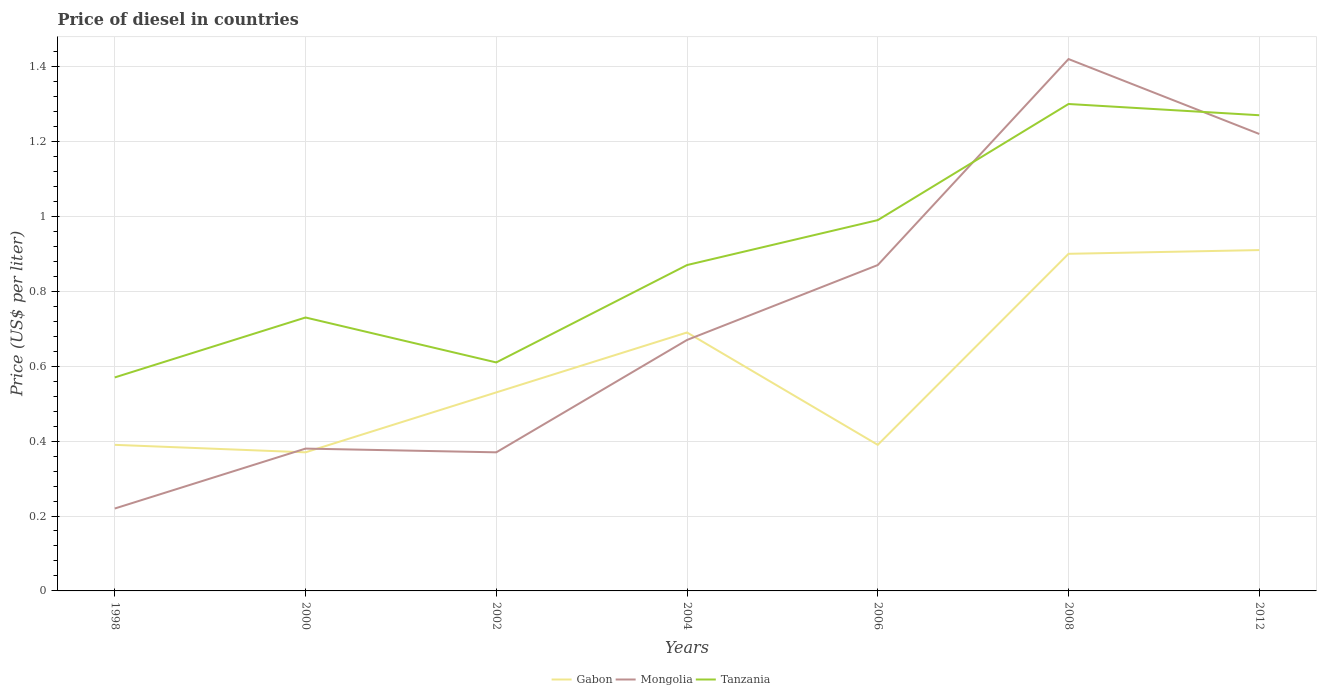Is the number of lines equal to the number of legend labels?
Provide a succinct answer. Yes. Across all years, what is the maximum price of diesel in Tanzania?
Make the answer very short. 0.57. In which year was the price of diesel in Tanzania maximum?
Your response must be concise. 1998. What is the difference between the highest and the second highest price of diesel in Tanzania?
Keep it short and to the point. 0.73. What is the difference between the highest and the lowest price of diesel in Gabon?
Offer a very short reply. 3. Is the price of diesel in Tanzania strictly greater than the price of diesel in Mongolia over the years?
Make the answer very short. No. What is the difference between two consecutive major ticks on the Y-axis?
Make the answer very short. 0.2. Are the values on the major ticks of Y-axis written in scientific E-notation?
Provide a short and direct response. No. Does the graph contain grids?
Provide a short and direct response. Yes. How are the legend labels stacked?
Make the answer very short. Horizontal. What is the title of the graph?
Ensure brevity in your answer.  Price of diesel in countries. What is the label or title of the X-axis?
Offer a very short reply. Years. What is the label or title of the Y-axis?
Provide a short and direct response. Price (US$ per liter). What is the Price (US$ per liter) of Gabon in 1998?
Ensure brevity in your answer.  0.39. What is the Price (US$ per liter) of Mongolia in 1998?
Offer a terse response. 0.22. What is the Price (US$ per liter) of Tanzania in 1998?
Ensure brevity in your answer.  0.57. What is the Price (US$ per liter) in Gabon in 2000?
Your answer should be compact. 0.37. What is the Price (US$ per liter) of Mongolia in 2000?
Provide a succinct answer. 0.38. What is the Price (US$ per liter) in Tanzania in 2000?
Your answer should be compact. 0.73. What is the Price (US$ per liter) of Gabon in 2002?
Your answer should be very brief. 0.53. What is the Price (US$ per liter) in Mongolia in 2002?
Your answer should be compact. 0.37. What is the Price (US$ per liter) of Tanzania in 2002?
Provide a succinct answer. 0.61. What is the Price (US$ per liter) in Gabon in 2004?
Offer a very short reply. 0.69. What is the Price (US$ per liter) of Mongolia in 2004?
Your answer should be compact. 0.67. What is the Price (US$ per liter) of Tanzania in 2004?
Make the answer very short. 0.87. What is the Price (US$ per liter) in Gabon in 2006?
Offer a terse response. 0.39. What is the Price (US$ per liter) in Mongolia in 2006?
Your response must be concise. 0.87. What is the Price (US$ per liter) in Tanzania in 2006?
Provide a short and direct response. 0.99. What is the Price (US$ per liter) in Gabon in 2008?
Keep it short and to the point. 0.9. What is the Price (US$ per liter) in Mongolia in 2008?
Your response must be concise. 1.42. What is the Price (US$ per liter) of Gabon in 2012?
Keep it short and to the point. 0.91. What is the Price (US$ per liter) of Mongolia in 2012?
Give a very brief answer. 1.22. What is the Price (US$ per liter) in Tanzania in 2012?
Your response must be concise. 1.27. Across all years, what is the maximum Price (US$ per liter) of Gabon?
Offer a terse response. 0.91. Across all years, what is the maximum Price (US$ per liter) in Mongolia?
Provide a short and direct response. 1.42. Across all years, what is the minimum Price (US$ per liter) of Gabon?
Offer a very short reply. 0.37. Across all years, what is the minimum Price (US$ per liter) in Mongolia?
Your answer should be compact. 0.22. Across all years, what is the minimum Price (US$ per liter) in Tanzania?
Offer a terse response. 0.57. What is the total Price (US$ per liter) of Gabon in the graph?
Your response must be concise. 4.18. What is the total Price (US$ per liter) of Mongolia in the graph?
Provide a short and direct response. 5.15. What is the total Price (US$ per liter) of Tanzania in the graph?
Ensure brevity in your answer.  6.34. What is the difference between the Price (US$ per liter) in Gabon in 1998 and that in 2000?
Your answer should be very brief. 0.02. What is the difference between the Price (US$ per liter) in Mongolia in 1998 and that in 2000?
Offer a very short reply. -0.16. What is the difference between the Price (US$ per liter) of Tanzania in 1998 and that in 2000?
Ensure brevity in your answer.  -0.16. What is the difference between the Price (US$ per liter) in Gabon in 1998 and that in 2002?
Ensure brevity in your answer.  -0.14. What is the difference between the Price (US$ per liter) in Mongolia in 1998 and that in 2002?
Give a very brief answer. -0.15. What is the difference between the Price (US$ per liter) in Tanzania in 1998 and that in 2002?
Your answer should be very brief. -0.04. What is the difference between the Price (US$ per liter) of Mongolia in 1998 and that in 2004?
Give a very brief answer. -0.45. What is the difference between the Price (US$ per liter) in Tanzania in 1998 and that in 2004?
Provide a short and direct response. -0.3. What is the difference between the Price (US$ per liter) in Mongolia in 1998 and that in 2006?
Give a very brief answer. -0.65. What is the difference between the Price (US$ per liter) in Tanzania in 1998 and that in 2006?
Make the answer very short. -0.42. What is the difference between the Price (US$ per liter) in Gabon in 1998 and that in 2008?
Keep it short and to the point. -0.51. What is the difference between the Price (US$ per liter) of Tanzania in 1998 and that in 2008?
Ensure brevity in your answer.  -0.73. What is the difference between the Price (US$ per liter) of Gabon in 1998 and that in 2012?
Give a very brief answer. -0.52. What is the difference between the Price (US$ per liter) in Tanzania in 1998 and that in 2012?
Give a very brief answer. -0.7. What is the difference between the Price (US$ per liter) in Gabon in 2000 and that in 2002?
Ensure brevity in your answer.  -0.16. What is the difference between the Price (US$ per liter) of Tanzania in 2000 and that in 2002?
Provide a succinct answer. 0.12. What is the difference between the Price (US$ per liter) of Gabon in 2000 and that in 2004?
Give a very brief answer. -0.32. What is the difference between the Price (US$ per liter) in Mongolia in 2000 and that in 2004?
Provide a short and direct response. -0.29. What is the difference between the Price (US$ per liter) of Tanzania in 2000 and that in 2004?
Offer a very short reply. -0.14. What is the difference between the Price (US$ per liter) in Gabon in 2000 and that in 2006?
Provide a succinct answer. -0.02. What is the difference between the Price (US$ per liter) in Mongolia in 2000 and that in 2006?
Your answer should be compact. -0.49. What is the difference between the Price (US$ per liter) in Tanzania in 2000 and that in 2006?
Your answer should be compact. -0.26. What is the difference between the Price (US$ per liter) in Gabon in 2000 and that in 2008?
Make the answer very short. -0.53. What is the difference between the Price (US$ per liter) in Mongolia in 2000 and that in 2008?
Your response must be concise. -1.04. What is the difference between the Price (US$ per liter) in Tanzania in 2000 and that in 2008?
Offer a very short reply. -0.57. What is the difference between the Price (US$ per liter) of Gabon in 2000 and that in 2012?
Provide a succinct answer. -0.54. What is the difference between the Price (US$ per liter) in Mongolia in 2000 and that in 2012?
Provide a succinct answer. -0.84. What is the difference between the Price (US$ per liter) of Tanzania in 2000 and that in 2012?
Make the answer very short. -0.54. What is the difference between the Price (US$ per liter) in Gabon in 2002 and that in 2004?
Ensure brevity in your answer.  -0.16. What is the difference between the Price (US$ per liter) in Tanzania in 2002 and that in 2004?
Ensure brevity in your answer.  -0.26. What is the difference between the Price (US$ per liter) of Gabon in 2002 and that in 2006?
Provide a succinct answer. 0.14. What is the difference between the Price (US$ per liter) in Tanzania in 2002 and that in 2006?
Keep it short and to the point. -0.38. What is the difference between the Price (US$ per liter) in Gabon in 2002 and that in 2008?
Offer a terse response. -0.37. What is the difference between the Price (US$ per liter) in Mongolia in 2002 and that in 2008?
Your response must be concise. -1.05. What is the difference between the Price (US$ per liter) of Tanzania in 2002 and that in 2008?
Offer a very short reply. -0.69. What is the difference between the Price (US$ per liter) of Gabon in 2002 and that in 2012?
Give a very brief answer. -0.38. What is the difference between the Price (US$ per liter) in Mongolia in 2002 and that in 2012?
Make the answer very short. -0.85. What is the difference between the Price (US$ per liter) in Tanzania in 2002 and that in 2012?
Your response must be concise. -0.66. What is the difference between the Price (US$ per liter) in Tanzania in 2004 and that in 2006?
Ensure brevity in your answer.  -0.12. What is the difference between the Price (US$ per liter) in Gabon in 2004 and that in 2008?
Your response must be concise. -0.21. What is the difference between the Price (US$ per liter) in Mongolia in 2004 and that in 2008?
Provide a succinct answer. -0.75. What is the difference between the Price (US$ per liter) of Tanzania in 2004 and that in 2008?
Provide a succinct answer. -0.43. What is the difference between the Price (US$ per liter) in Gabon in 2004 and that in 2012?
Offer a terse response. -0.22. What is the difference between the Price (US$ per liter) of Mongolia in 2004 and that in 2012?
Keep it short and to the point. -0.55. What is the difference between the Price (US$ per liter) of Gabon in 2006 and that in 2008?
Your answer should be very brief. -0.51. What is the difference between the Price (US$ per liter) in Mongolia in 2006 and that in 2008?
Keep it short and to the point. -0.55. What is the difference between the Price (US$ per liter) in Tanzania in 2006 and that in 2008?
Give a very brief answer. -0.31. What is the difference between the Price (US$ per liter) in Gabon in 2006 and that in 2012?
Give a very brief answer. -0.52. What is the difference between the Price (US$ per liter) in Mongolia in 2006 and that in 2012?
Give a very brief answer. -0.35. What is the difference between the Price (US$ per liter) of Tanzania in 2006 and that in 2012?
Provide a succinct answer. -0.28. What is the difference between the Price (US$ per liter) in Gabon in 2008 and that in 2012?
Make the answer very short. -0.01. What is the difference between the Price (US$ per liter) of Mongolia in 2008 and that in 2012?
Your answer should be compact. 0.2. What is the difference between the Price (US$ per liter) in Tanzania in 2008 and that in 2012?
Keep it short and to the point. 0.03. What is the difference between the Price (US$ per liter) in Gabon in 1998 and the Price (US$ per liter) in Tanzania in 2000?
Make the answer very short. -0.34. What is the difference between the Price (US$ per liter) of Mongolia in 1998 and the Price (US$ per liter) of Tanzania in 2000?
Your answer should be compact. -0.51. What is the difference between the Price (US$ per liter) in Gabon in 1998 and the Price (US$ per liter) in Tanzania in 2002?
Ensure brevity in your answer.  -0.22. What is the difference between the Price (US$ per liter) in Mongolia in 1998 and the Price (US$ per liter) in Tanzania in 2002?
Offer a terse response. -0.39. What is the difference between the Price (US$ per liter) in Gabon in 1998 and the Price (US$ per liter) in Mongolia in 2004?
Make the answer very short. -0.28. What is the difference between the Price (US$ per liter) of Gabon in 1998 and the Price (US$ per liter) of Tanzania in 2004?
Your answer should be very brief. -0.48. What is the difference between the Price (US$ per liter) of Mongolia in 1998 and the Price (US$ per liter) of Tanzania in 2004?
Offer a very short reply. -0.65. What is the difference between the Price (US$ per liter) of Gabon in 1998 and the Price (US$ per liter) of Mongolia in 2006?
Your response must be concise. -0.48. What is the difference between the Price (US$ per liter) of Gabon in 1998 and the Price (US$ per liter) of Tanzania in 2006?
Offer a very short reply. -0.6. What is the difference between the Price (US$ per liter) of Mongolia in 1998 and the Price (US$ per liter) of Tanzania in 2006?
Offer a very short reply. -0.77. What is the difference between the Price (US$ per liter) of Gabon in 1998 and the Price (US$ per liter) of Mongolia in 2008?
Ensure brevity in your answer.  -1.03. What is the difference between the Price (US$ per liter) in Gabon in 1998 and the Price (US$ per liter) in Tanzania in 2008?
Your answer should be very brief. -0.91. What is the difference between the Price (US$ per liter) in Mongolia in 1998 and the Price (US$ per liter) in Tanzania in 2008?
Offer a very short reply. -1.08. What is the difference between the Price (US$ per liter) in Gabon in 1998 and the Price (US$ per liter) in Mongolia in 2012?
Give a very brief answer. -0.83. What is the difference between the Price (US$ per liter) of Gabon in 1998 and the Price (US$ per liter) of Tanzania in 2012?
Offer a terse response. -0.88. What is the difference between the Price (US$ per liter) in Mongolia in 1998 and the Price (US$ per liter) in Tanzania in 2012?
Your answer should be very brief. -1.05. What is the difference between the Price (US$ per liter) of Gabon in 2000 and the Price (US$ per liter) of Mongolia in 2002?
Offer a terse response. 0. What is the difference between the Price (US$ per liter) of Gabon in 2000 and the Price (US$ per liter) of Tanzania in 2002?
Offer a terse response. -0.24. What is the difference between the Price (US$ per liter) in Mongolia in 2000 and the Price (US$ per liter) in Tanzania in 2002?
Ensure brevity in your answer.  -0.23. What is the difference between the Price (US$ per liter) of Mongolia in 2000 and the Price (US$ per liter) of Tanzania in 2004?
Keep it short and to the point. -0.49. What is the difference between the Price (US$ per liter) of Gabon in 2000 and the Price (US$ per liter) of Tanzania in 2006?
Offer a terse response. -0.62. What is the difference between the Price (US$ per liter) in Mongolia in 2000 and the Price (US$ per liter) in Tanzania in 2006?
Keep it short and to the point. -0.61. What is the difference between the Price (US$ per liter) of Gabon in 2000 and the Price (US$ per liter) of Mongolia in 2008?
Ensure brevity in your answer.  -1.05. What is the difference between the Price (US$ per liter) of Gabon in 2000 and the Price (US$ per liter) of Tanzania in 2008?
Keep it short and to the point. -0.93. What is the difference between the Price (US$ per liter) of Mongolia in 2000 and the Price (US$ per liter) of Tanzania in 2008?
Give a very brief answer. -0.92. What is the difference between the Price (US$ per liter) in Gabon in 2000 and the Price (US$ per liter) in Mongolia in 2012?
Make the answer very short. -0.85. What is the difference between the Price (US$ per liter) of Mongolia in 2000 and the Price (US$ per liter) of Tanzania in 2012?
Provide a short and direct response. -0.89. What is the difference between the Price (US$ per liter) of Gabon in 2002 and the Price (US$ per liter) of Mongolia in 2004?
Give a very brief answer. -0.14. What is the difference between the Price (US$ per liter) in Gabon in 2002 and the Price (US$ per liter) in Tanzania in 2004?
Ensure brevity in your answer.  -0.34. What is the difference between the Price (US$ per liter) of Gabon in 2002 and the Price (US$ per liter) of Mongolia in 2006?
Provide a succinct answer. -0.34. What is the difference between the Price (US$ per liter) in Gabon in 2002 and the Price (US$ per liter) in Tanzania in 2006?
Ensure brevity in your answer.  -0.46. What is the difference between the Price (US$ per liter) of Mongolia in 2002 and the Price (US$ per liter) of Tanzania in 2006?
Provide a succinct answer. -0.62. What is the difference between the Price (US$ per liter) of Gabon in 2002 and the Price (US$ per liter) of Mongolia in 2008?
Give a very brief answer. -0.89. What is the difference between the Price (US$ per liter) in Gabon in 2002 and the Price (US$ per liter) in Tanzania in 2008?
Provide a short and direct response. -0.77. What is the difference between the Price (US$ per liter) in Mongolia in 2002 and the Price (US$ per liter) in Tanzania in 2008?
Keep it short and to the point. -0.93. What is the difference between the Price (US$ per liter) in Gabon in 2002 and the Price (US$ per liter) in Mongolia in 2012?
Your answer should be compact. -0.69. What is the difference between the Price (US$ per liter) of Gabon in 2002 and the Price (US$ per liter) of Tanzania in 2012?
Ensure brevity in your answer.  -0.74. What is the difference between the Price (US$ per liter) of Gabon in 2004 and the Price (US$ per liter) of Mongolia in 2006?
Keep it short and to the point. -0.18. What is the difference between the Price (US$ per liter) in Mongolia in 2004 and the Price (US$ per liter) in Tanzania in 2006?
Ensure brevity in your answer.  -0.32. What is the difference between the Price (US$ per liter) of Gabon in 2004 and the Price (US$ per liter) of Mongolia in 2008?
Provide a succinct answer. -0.73. What is the difference between the Price (US$ per liter) in Gabon in 2004 and the Price (US$ per liter) in Tanzania in 2008?
Provide a short and direct response. -0.61. What is the difference between the Price (US$ per liter) of Mongolia in 2004 and the Price (US$ per liter) of Tanzania in 2008?
Offer a terse response. -0.63. What is the difference between the Price (US$ per liter) in Gabon in 2004 and the Price (US$ per liter) in Mongolia in 2012?
Your answer should be compact. -0.53. What is the difference between the Price (US$ per liter) in Gabon in 2004 and the Price (US$ per liter) in Tanzania in 2012?
Give a very brief answer. -0.58. What is the difference between the Price (US$ per liter) in Mongolia in 2004 and the Price (US$ per liter) in Tanzania in 2012?
Provide a succinct answer. -0.6. What is the difference between the Price (US$ per liter) of Gabon in 2006 and the Price (US$ per liter) of Mongolia in 2008?
Ensure brevity in your answer.  -1.03. What is the difference between the Price (US$ per liter) of Gabon in 2006 and the Price (US$ per liter) of Tanzania in 2008?
Make the answer very short. -0.91. What is the difference between the Price (US$ per liter) in Mongolia in 2006 and the Price (US$ per liter) in Tanzania in 2008?
Offer a very short reply. -0.43. What is the difference between the Price (US$ per liter) in Gabon in 2006 and the Price (US$ per liter) in Mongolia in 2012?
Offer a terse response. -0.83. What is the difference between the Price (US$ per liter) of Gabon in 2006 and the Price (US$ per liter) of Tanzania in 2012?
Provide a short and direct response. -0.88. What is the difference between the Price (US$ per liter) in Gabon in 2008 and the Price (US$ per liter) in Mongolia in 2012?
Keep it short and to the point. -0.32. What is the difference between the Price (US$ per liter) of Gabon in 2008 and the Price (US$ per liter) of Tanzania in 2012?
Provide a short and direct response. -0.37. What is the average Price (US$ per liter) of Gabon per year?
Provide a succinct answer. 0.6. What is the average Price (US$ per liter) in Mongolia per year?
Offer a terse response. 0.74. What is the average Price (US$ per liter) of Tanzania per year?
Keep it short and to the point. 0.91. In the year 1998, what is the difference between the Price (US$ per liter) of Gabon and Price (US$ per liter) of Mongolia?
Ensure brevity in your answer.  0.17. In the year 1998, what is the difference between the Price (US$ per liter) of Gabon and Price (US$ per liter) of Tanzania?
Your answer should be very brief. -0.18. In the year 1998, what is the difference between the Price (US$ per liter) of Mongolia and Price (US$ per liter) of Tanzania?
Your answer should be very brief. -0.35. In the year 2000, what is the difference between the Price (US$ per liter) in Gabon and Price (US$ per liter) in Mongolia?
Provide a short and direct response. -0.01. In the year 2000, what is the difference between the Price (US$ per liter) in Gabon and Price (US$ per liter) in Tanzania?
Make the answer very short. -0.36. In the year 2000, what is the difference between the Price (US$ per liter) in Mongolia and Price (US$ per liter) in Tanzania?
Your answer should be very brief. -0.35. In the year 2002, what is the difference between the Price (US$ per liter) of Gabon and Price (US$ per liter) of Mongolia?
Keep it short and to the point. 0.16. In the year 2002, what is the difference between the Price (US$ per liter) in Gabon and Price (US$ per liter) in Tanzania?
Your response must be concise. -0.08. In the year 2002, what is the difference between the Price (US$ per liter) in Mongolia and Price (US$ per liter) in Tanzania?
Offer a terse response. -0.24. In the year 2004, what is the difference between the Price (US$ per liter) in Gabon and Price (US$ per liter) in Mongolia?
Your response must be concise. 0.02. In the year 2004, what is the difference between the Price (US$ per liter) in Gabon and Price (US$ per liter) in Tanzania?
Offer a very short reply. -0.18. In the year 2006, what is the difference between the Price (US$ per liter) in Gabon and Price (US$ per liter) in Mongolia?
Make the answer very short. -0.48. In the year 2006, what is the difference between the Price (US$ per liter) of Mongolia and Price (US$ per liter) of Tanzania?
Make the answer very short. -0.12. In the year 2008, what is the difference between the Price (US$ per liter) of Gabon and Price (US$ per liter) of Mongolia?
Your answer should be compact. -0.52. In the year 2008, what is the difference between the Price (US$ per liter) of Mongolia and Price (US$ per liter) of Tanzania?
Your answer should be very brief. 0.12. In the year 2012, what is the difference between the Price (US$ per liter) of Gabon and Price (US$ per liter) of Mongolia?
Your response must be concise. -0.31. In the year 2012, what is the difference between the Price (US$ per liter) in Gabon and Price (US$ per liter) in Tanzania?
Offer a terse response. -0.36. In the year 2012, what is the difference between the Price (US$ per liter) in Mongolia and Price (US$ per liter) in Tanzania?
Your answer should be compact. -0.05. What is the ratio of the Price (US$ per liter) of Gabon in 1998 to that in 2000?
Your answer should be compact. 1.05. What is the ratio of the Price (US$ per liter) in Mongolia in 1998 to that in 2000?
Make the answer very short. 0.58. What is the ratio of the Price (US$ per liter) in Tanzania in 1998 to that in 2000?
Make the answer very short. 0.78. What is the ratio of the Price (US$ per liter) in Gabon in 1998 to that in 2002?
Your response must be concise. 0.74. What is the ratio of the Price (US$ per liter) of Mongolia in 1998 to that in 2002?
Keep it short and to the point. 0.59. What is the ratio of the Price (US$ per liter) in Tanzania in 1998 to that in 2002?
Offer a terse response. 0.93. What is the ratio of the Price (US$ per liter) of Gabon in 1998 to that in 2004?
Keep it short and to the point. 0.57. What is the ratio of the Price (US$ per liter) of Mongolia in 1998 to that in 2004?
Offer a very short reply. 0.33. What is the ratio of the Price (US$ per liter) of Tanzania in 1998 to that in 2004?
Your answer should be compact. 0.66. What is the ratio of the Price (US$ per liter) of Gabon in 1998 to that in 2006?
Your answer should be very brief. 1. What is the ratio of the Price (US$ per liter) in Mongolia in 1998 to that in 2006?
Offer a terse response. 0.25. What is the ratio of the Price (US$ per liter) of Tanzania in 1998 to that in 2006?
Provide a short and direct response. 0.58. What is the ratio of the Price (US$ per liter) in Gabon in 1998 to that in 2008?
Provide a short and direct response. 0.43. What is the ratio of the Price (US$ per liter) of Mongolia in 1998 to that in 2008?
Keep it short and to the point. 0.15. What is the ratio of the Price (US$ per liter) of Tanzania in 1998 to that in 2008?
Make the answer very short. 0.44. What is the ratio of the Price (US$ per liter) of Gabon in 1998 to that in 2012?
Offer a terse response. 0.43. What is the ratio of the Price (US$ per liter) of Mongolia in 1998 to that in 2012?
Your response must be concise. 0.18. What is the ratio of the Price (US$ per liter) of Tanzania in 1998 to that in 2012?
Keep it short and to the point. 0.45. What is the ratio of the Price (US$ per liter) of Gabon in 2000 to that in 2002?
Ensure brevity in your answer.  0.7. What is the ratio of the Price (US$ per liter) in Tanzania in 2000 to that in 2002?
Make the answer very short. 1.2. What is the ratio of the Price (US$ per liter) in Gabon in 2000 to that in 2004?
Provide a succinct answer. 0.54. What is the ratio of the Price (US$ per liter) in Mongolia in 2000 to that in 2004?
Your answer should be very brief. 0.57. What is the ratio of the Price (US$ per liter) of Tanzania in 2000 to that in 2004?
Your answer should be very brief. 0.84. What is the ratio of the Price (US$ per liter) in Gabon in 2000 to that in 2006?
Offer a terse response. 0.95. What is the ratio of the Price (US$ per liter) of Mongolia in 2000 to that in 2006?
Offer a very short reply. 0.44. What is the ratio of the Price (US$ per liter) in Tanzania in 2000 to that in 2006?
Your answer should be compact. 0.74. What is the ratio of the Price (US$ per liter) in Gabon in 2000 to that in 2008?
Provide a succinct answer. 0.41. What is the ratio of the Price (US$ per liter) in Mongolia in 2000 to that in 2008?
Your response must be concise. 0.27. What is the ratio of the Price (US$ per liter) of Tanzania in 2000 to that in 2008?
Offer a very short reply. 0.56. What is the ratio of the Price (US$ per liter) of Gabon in 2000 to that in 2012?
Give a very brief answer. 0.41. What is the ratio of the Price (US$ per liter) of Mongolia in 2000 to that in 2012?
Provide a succinct answer. 0.31. What is the ratio of the Price (US$ per liter) in Tanzania in 2000 to that in 2012?
Your answer should be very brief. 0.57. What is the ratio of the Price (US$ per liter) in Gabon in 2002 to that in 2004?
Give a very brief answer. 0.77. What is the ratio of the Price (US$ per liter) in Mongolia in 2002 to that in 2004?
Offer a very short reply. 0.55. What is the ratio of the Price (US$ per liter) of Tanzania in 2002 to that in 2004?
Offer a very short reply. 0.7. What is the ratio of the Price (US$ per liter) in Gabon in 2002 to that in 2006?
Your answer should be compact. 1.36. What is the ratio of the Price (US$ per liter) of Mongolia in 2002 to that in 2006?
Make the answer very short. 0.43. What is the ratio of the Price (US$ per liter) of Tanzania in 2002 to that in 2006?
Your answer should be compact. 0.62. What is the ratio of the Price (US$ per liter) of Gabon in 2002 to that in 2008?
Make the answer very short. 0.59. What is the ratio of the Price (US$ per liter) of Mongolia in 2002 to that in 2008?
Keep it short and to the point. 0.26. What is the ratio of the Price (US$ per liter) in Tanzania in 2002 to that in 2008?
Ensure brevity in your answer.  0.47. What is the ratio of the Price (US$ per liter) in Gabon in 2002 to that in 2012?
Offer a terse response. 0.58. What is the ratio of the Price (US$ per liter) of Mongolia in 2002 to that in 2012?
Ensure brevity in your answer.  0.3. What is the ratio of the Price (US$ per liter) of Tanzania in 2002 to that in 2012?
Offer a very short reply. 0.48. What is the ratio of the Price (US$ per liter) of Gabon in 2004 to that in 2006?
Ensure brevity in your answer.  1.77. What is the ratio of the Price (US$ per liter) of Mongolia in 2004 to that in 2006?
Provide a short and direct response. 0.77. What is the ratio of the Price (US$ per liter) in Tanzania in 2004 to that in 2006?
Offer a terse response. 0.88. What is the ratio of the Price (US$ per liter) in Gabon in 2004 to that in 2008?
Offer a terse response. 0.77. What is the ratio of the Price (US$ per liter) in Mongolia in 2004 to that in 2008?
Provide a short and direct response. 0.47. What is the ratio of the Price (US$ per liter) of Tanzania in 2004 to that in 2008?
Make the answer very short. 0.67. What is the ratio of the Price (US$ per liter) in Gabon in 2004 to that in 2012?
Make the answer very short. 0.76. What is the ratio of the Price (US$ per liter) in Mongolia in 2004 to that in 2012?
Provide a short and direct response. 0.55. What is the ratio of the Price (US$ per liter) in Tanzania in 2004 to that in 2012?
Keep it short and to the point. 0.69. What is the ratio of the Price (US$ per liter) in Gabon in 2006 to that in 2008?
Keep it short and to the point. 0.43. What is the ratio of the Price (US$ per liter) in Mongolia in 2006 to that in 2008?
Your answer should be very brief. 0.61. What is the ratio of the Price (US$ per liter) of Tanzania in 2006 to that in 2008?
Your answer should be compact. 0.76. What is the ratio of the Price (US$ per liter) of Gabon in 2006 to that in 2012?
Your answer should be very brief. 0.43. What is the ratio of the Price (US$ per liter) of Mongolia in 2006 to that in 2012?
Make the answer very short. 0.71. What is the ratio of the Price (US$ per liter) of Tanzania in 2006 to that in 2012?
Your response must be concise. 0.78. What is the ratio of the Price (US$ per liter) in Gabon in 2008 to that in 2012?
Make the answer very short. 0.99. What is the ratio of the Price (US$ per liter) of Mongolia in 2008 to that in 2012?
Provide a succinct answer. 1.16. What is the ratio of the Price (US$ per liter) of Tanzania in 2008 to that in 2012?
Make the answer very short. 1.02. What is the difference between the highest and the second highest Price (US$ per liter) in Gabon?
Offer a very short reply. 0.01. What is the difference between the highest and the second highest Price (US$ per liter) in Tanzania?
Your response must be concise. 0.03. What is the difference between the highest and the lowest Price (US$ per liter) in Gabon?
Keep it short and to the point. 0.54. What is the difference between the highest and the lowest Price (US$ per liter) of Mongolia?
Make the answer very short. 1.2. What is the difference between the highest and the lowest Price (US$ per liter) of Tanzania?
Make the answer very short. 0.73. 